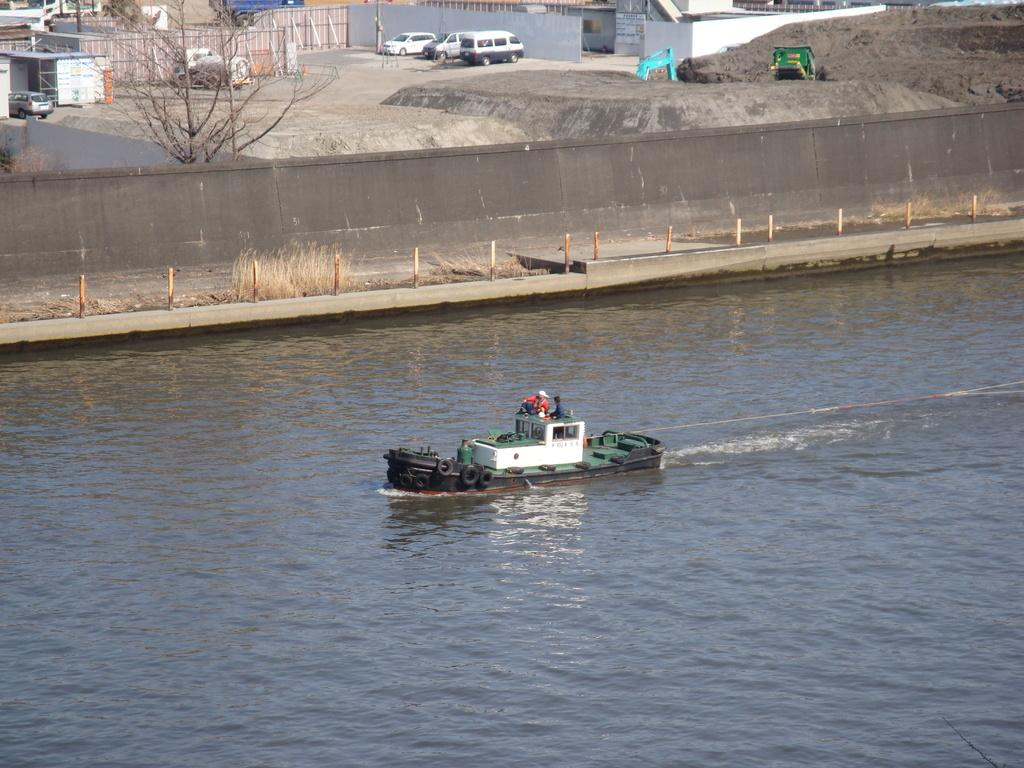What are the people in the image doing? The people in the image are on a boat. What is the primary setting of the image? There is water visible in the image. What type of vegetation can be seen in the image? There is grass in the image. What structures are present in the image? There are poles and a wall in the image. What can be seen in the background of the image? Trees, vehicles, and sheds are present in the background of the image. What type of camera is being used by the lawyer in the image? There is no camera or lawyer present in the image. What type of town can be seen in the background of the image? The image does not depict a town; it shows a boat on water with a background of trees, vehicles, and sheds. 